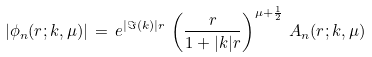<formula> <loc_0><loc_0><loc_500><loc_500>| \phi _ { n } ( r ; k , \mu ) | \, = \, e ^ { | \Im ( k ) | r } \, \left ( \frac { r } { 1 + | k | r } \right ) ^ { \mu + \frac { 1 } { 2 } } \, A _ { n } ( r ; k , \mu )</formula> 